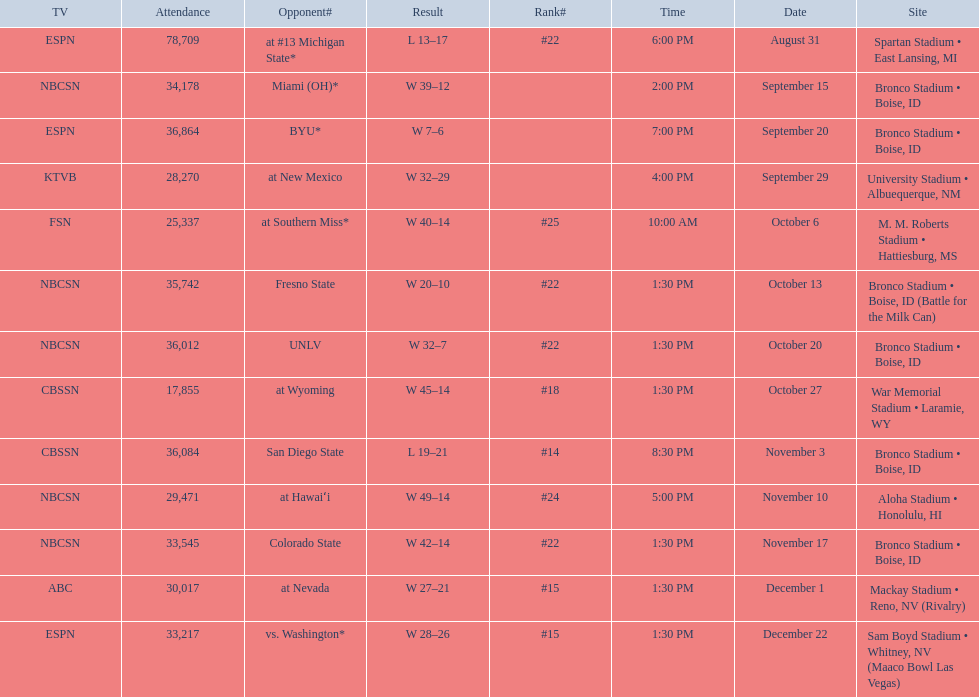What are the opponent teams of the 2012 boise state broncos football team? At #13 michigan state*, miami (oh)*, byu*, at new mexico, at southern miss*, fresno state, unlv, at wyoming, san diego state, at hawaiʻi, colorado state, at nevada, vs. washington*. How has the highest rank of these opponents? San Diego State. 